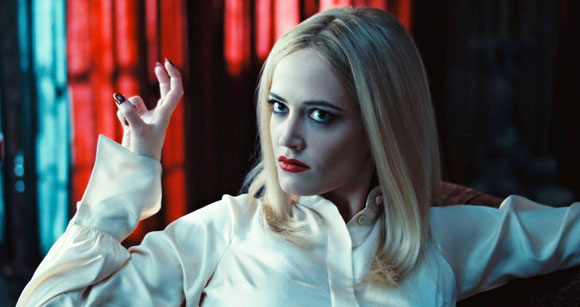What can you infer about the character's personality based on her expression and posture? The character's posture and expression suggest a central figure full of confidence and intrigue. Her direct gaze and the way her arms are spread out on the couch imply a sense of control and presence, often characteristic of a commanding or pivotal role in a narrative. Her intense expression, paired with her bold makeup, may indicate a character with a complex, dynamic persona possibly involved in dramatic or intense emotional experiences. 